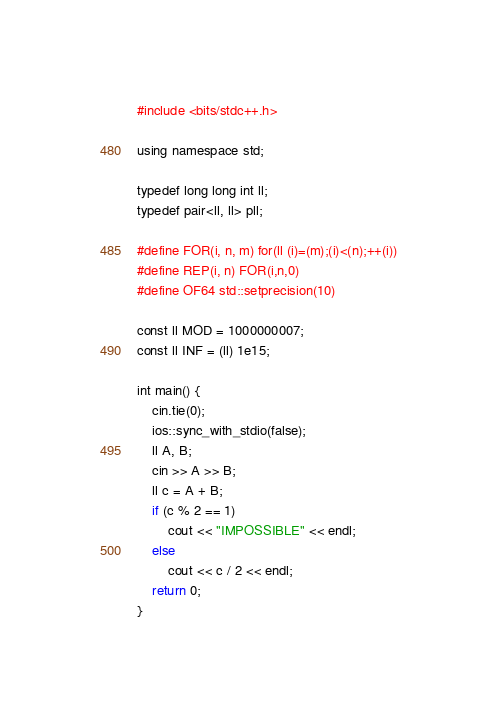Convert code to text. <code><loc_0><loc_0><loc_500><loc_500><_Python_>#include <bits/stdc++.h>

using namespace std;

typedef long long int ll;
typedef pair<ll, ll> pll;

#define FOR(i, n, m) for(ll (i)=(m);(i)<(n);++(i))
#define REP(i, n) FOR(i,n,0)
#define OF64 std::setprecision(10)

const ll MOD = 1000000007;
const ll INF = (ll) 1e15;

int main() {
    cin.tie(0);
    ios::sync_with_stdio(false);
    ll A, B;
    cin >> A >> B;
    ll c = A + B;
    if (c % 2 == 1)
        cout << "IMPOSSIBLE" << endl;
    else
        cout << c / 2 << endl;
    return 0;
}</code> 